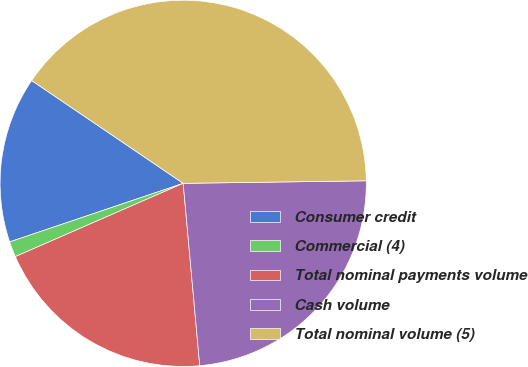<chart> <loc_0><loc_0><loc_500><loc_500><pie_chart><fcel>Consumer credit<fcel>Commercial (4)<fcel>Total nominal payments volume<fcel>Cash volume<fcel>Total nominal volume (5)<nl><fcel>14.67%<fcel>1.37%<fcel>19.89%<fcel>23.78%<fcel>40.29%<nl></chart> 